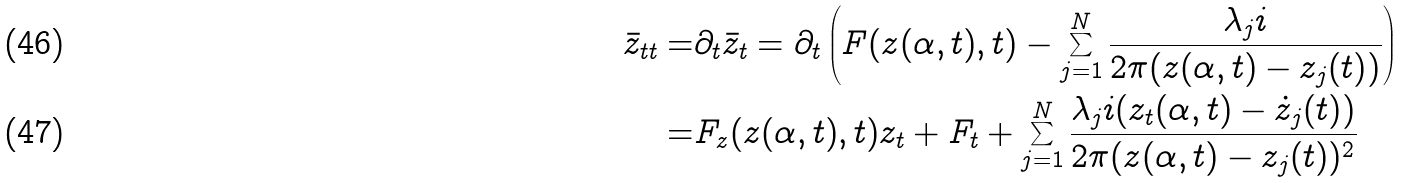<formula> <loc_0><loc_0><loc_500><loc_500>\bar { z } _ { t t } = & \partial _ { t } \bar { z } _ { t } = \partial _ { t } \left ( F ( z ( \alpha , t ) , t ) - \sum _ { j = 1 } ^ { N } \frac { \lambda _ { j } i } { 2 \pi ( z ( \alpha , t ) - z _ { j } ( t ) ) } \right ) \\ = & F _ { z } ( z ( \alpha , t ) , t ) z _ { t } + F _ { t } + \sum _ { j = 1 } ^ { N } \frac { \lambda _ { j } i ( z _ { t } ( \alpha , t ) - \dot { z } _ { j } ( t ) ) } { 2 \pi ( z ( \alpha , t ) - z _ { j } ( t ) ) ^ { 2 } }</formula> 